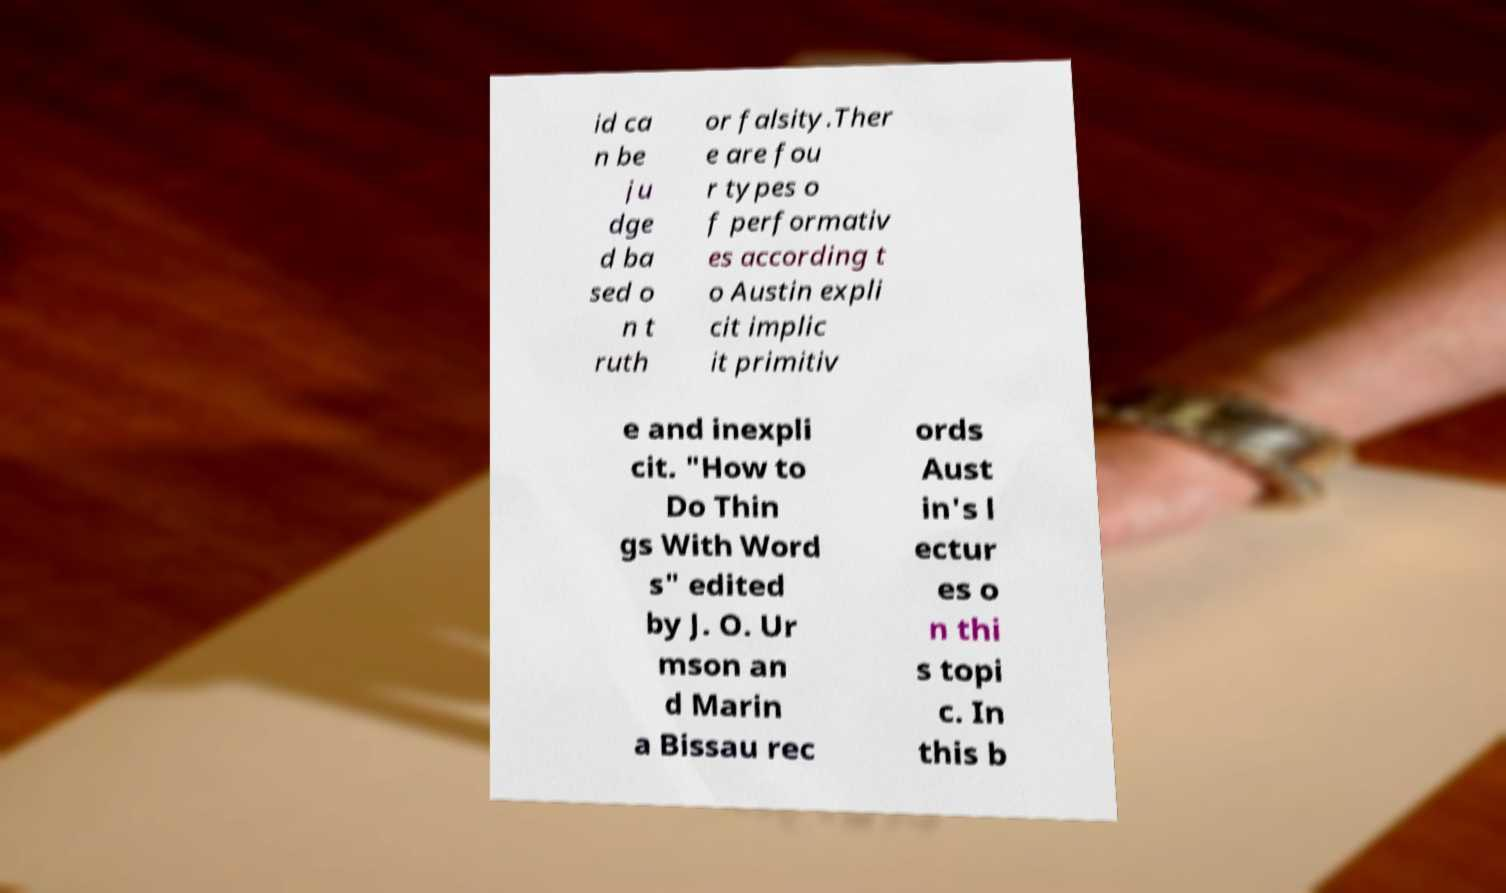For documentation purposes, I need the text within this image transcribed. Could you provide that? id ca n be ju dge d ba sed o n t ruth or falsity.Ther e are fou r types o f performativ es according t o Austin expli cit implic it primitiv e and inexpli cit. "How to Do Thin gs With Word s" edited by J. O. Ur mson an d Marin a Bissau rec ords Aust in's l ectur es o n thi s topi c. In this b 